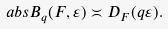<formula> <loc_0><loc_0><loc_500><loc_500>\ a b s { B _ { q } ( F , \varepsilon ) } \asymp D _ { F } ( q \varepsilon ) .</formula> 